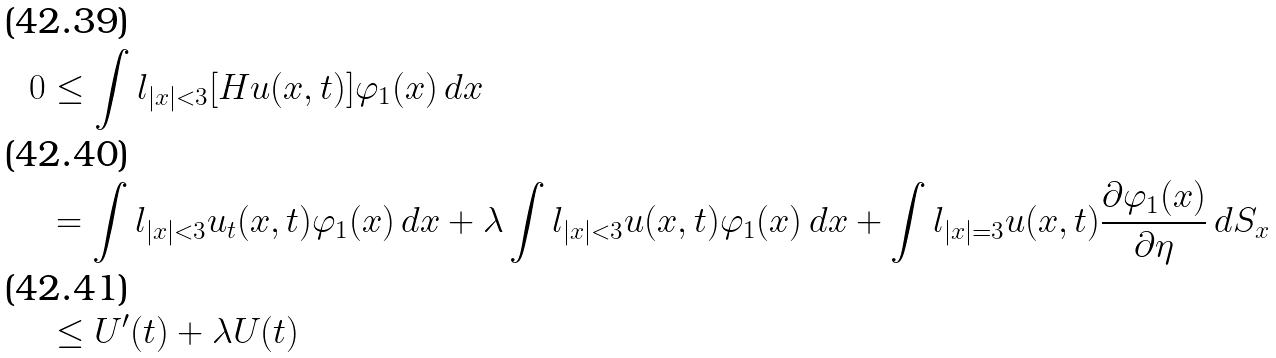Convert formula to latex. <formula><loc_0><loc_0><loc_500><loc_500>0 & \leq \int l _ { | x | < 3 } [ H u ( x , t ) ] \varphi _ { 1 } ( x ) \, d x \\ & = \int l _ { | x | < 3 } u _ { t } ( x , t ) \varphi _ { 1 } ( x ) \, d x + \lambda \int l _ { | x | < 3 } u ( x , t ) \varphi _ { 1 } ( x ) \, d x + \int l _ { | x | = 3 } u ( x , t ) \frac { \partial \varphi _ { 1 } ( x ) } { \partial \eta } \, d S _ { x } \\ & \leq U ^ { \prime } ( t ) + \lambda U ( t )</formula> 